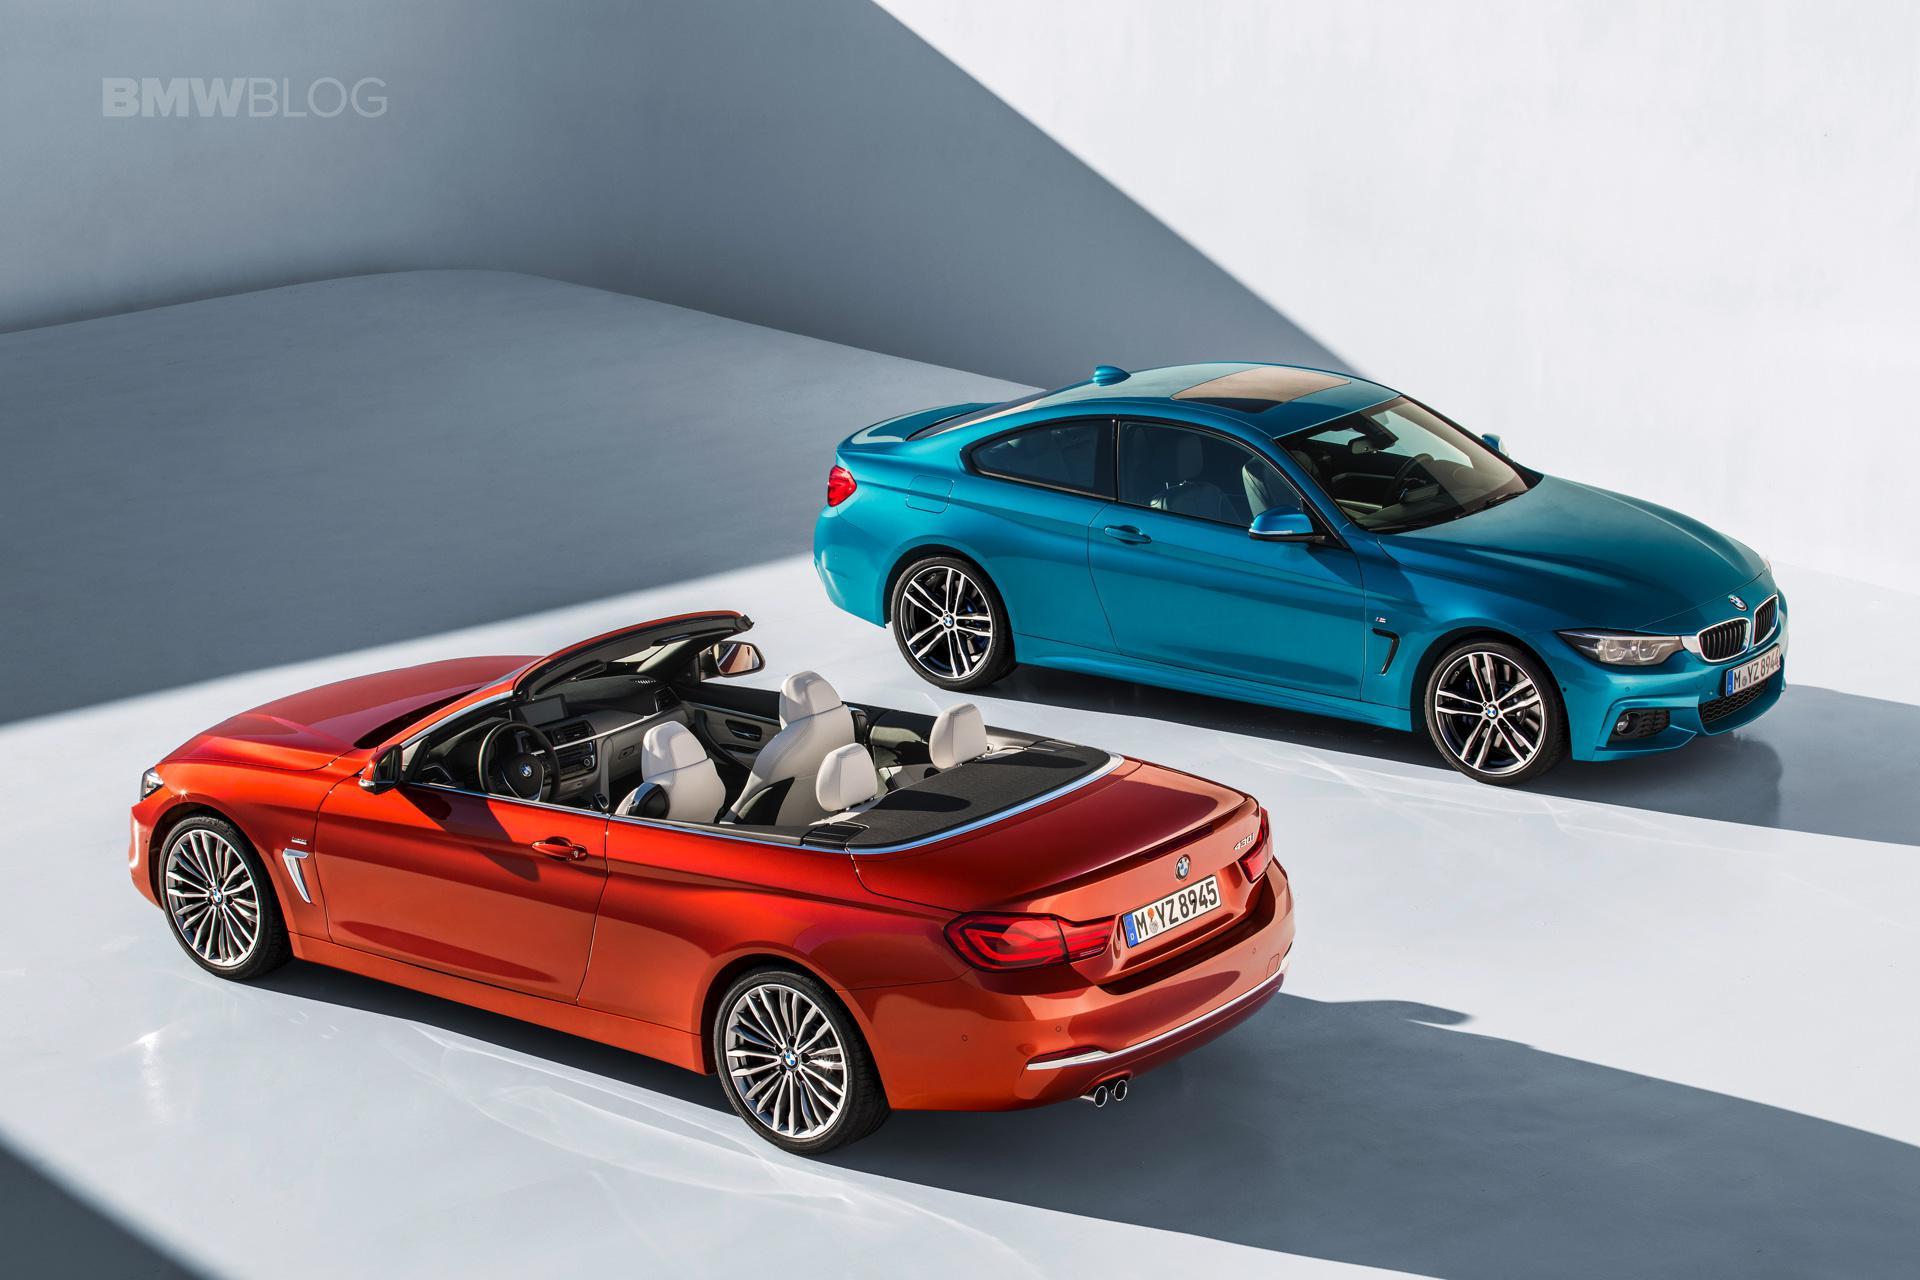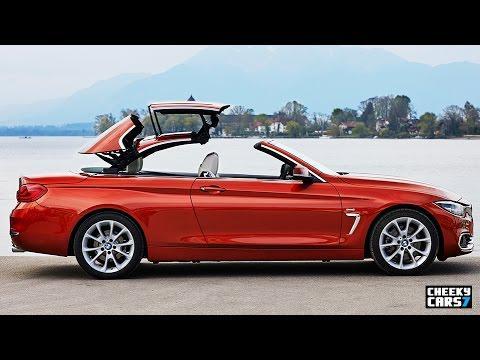The first image is the image on the left, the second image is the image on the right. Analyze the images presented: Is the assertion "One image features a red convertible and a blue car with a top, and the vehicles face opposite directions." valid? Answer yes or no. Yes. The first image is the image on the left, the second image is the image on the right. Analyze the images presented: Is the assertion "The left hand image shows one red and one blue car, while the right hand image shows exactly one red convertible vehicle." valid? Answer yes or no. Yes. 